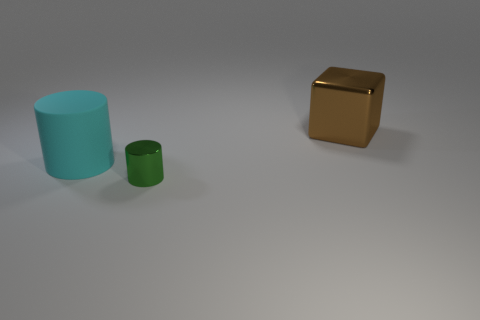Subtract all yellow cylinders. Subtract all blue balls. How many cylinders are left? 2 Add 2 metallic blocks. How many objects exist? 5 Subtract all blocks. How many objects are left? 2 Subtract 0 purple blocks. How many objects are left? 3 Subtract all tiny cyan shiny objects. Subtract all tiny things. How many objects are left? 2 Add 3 big brown metal blocks. How many big brown metal blocks are left? 4 Add 1 large cyan matte things. How many large cyan matte things exist? 2 